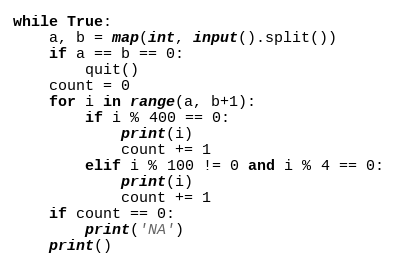<code> <loc_0><loc_0><loc_500><loc_500><_Python_>while True:
    a, b = map(int, input().split())
    if a == b == 0:
        quit()
    count = 0
    for i in range(a, b+1):
        if i % 400 == 0:
            print(i)
            count += 1
        elif i % 100 != 0 and i % 4 == 0:
            print(i)
            count += 1
    if count == 0:
        print('NA')
    print()
</code> 